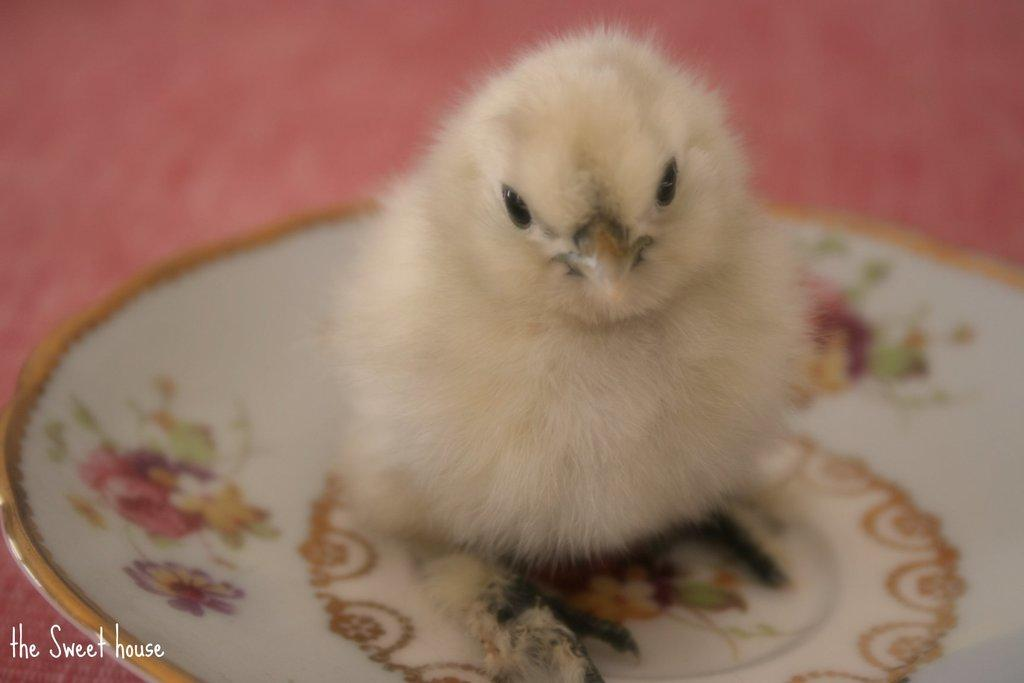What is the color of the plate in the image? The plate in the image is white. What is on top of the plate? There is a cream color bird on the plate. Is there any additional information or marking in the image? Yes, there is a watermark in the bottom left corner of the image. What type of frame surrounds the bird in the image? There is no frame surrounding the bird in the image; it is on a white plate. What direction is the bird facing in the image? The direction the bird is facing cannot be determined from the image, as it is a still image and does not show movement or orientation. 